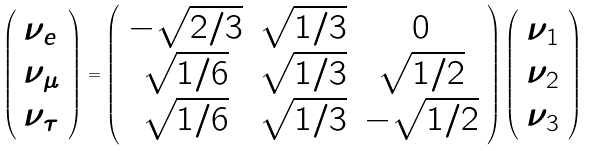<formula> <loc_0><loc_0><loc_500><loc_500>\left ( \begin{array} { l } \nu _ { e } \\ \nu _ { \mu } \\ \nu _ { \tau } \end{array} \right ) = \left ( \begin{array} { c c c } - \sqrt { 2 / 3 } & \sqrt { 1 / 3 } & 0 \\ \sqrt { 1 / 6 } & \sqrt { 1 / 3 } & \sqrt { 1 / 2 } \\ \sqrt { 1 / 6 } & \sqrt { 1 / 3 } & - \sqrt { 1 / 2 } \end{array} \right ) \left ( \begin{array} { l } \nu _ { 1 } \\ \nu _ { 2 } \\ \nu _ { 3 } \end{array} \right )</formula> 